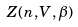Convert formula to latex. <formula><loc_0><loc_0><loc_500><loc_500>Z ( n , V , \beta )</formula> 